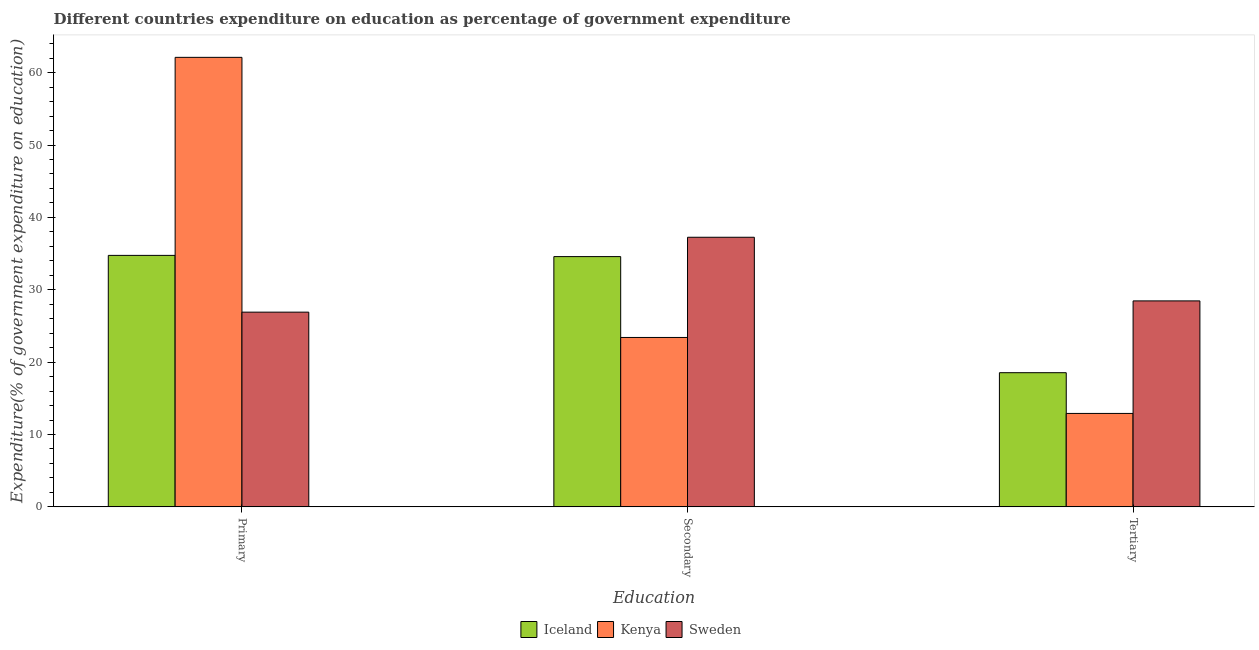How many different coloured bars are there?
Give a very brief answer. 3. How many bars are there on the 3rd tick from the left?
Ensure brevity in your answer.  3. How many bars are there on the 3rd tick from the right?
Provide a succinct answer. 3. What is the label of the 1st group of bars from the left?
Ensure brevity in your answer.  Primary. What is the expenditure on secondary education in Kenya?
Provide a succinct answer. 23.41. Across all countries, what is the maximum expenditure on secondary education?
Offer a very short reply. 37.26. Across all countries, what is the minimum expenditure on primary education?
Your response must be concise. 26.91. In which country was the expenditure on primary education maximum?
Offer a very short reply. Kenya. In which country was the expenditure on tertiary education minimum?
Make the answer very short. Kenya. What is the total expenditure on secondary education in the graph?
Give a very brief answer. 95.25. What is the difference between the expenditure on tertiary education in Iceland and that in Kenya?
Your answer should be very brief. 5.63. What is the difference between the expenditure on tertiary education in Iceland and the expenditure on secondary education in Kenya?
Make the answer very short. -4.87. What is the average expenditure on primary education per country?
Ensure brevity in your answer.  41.26. What is the difference between the expenditure on tertiary education and expenditure on secondary education in Iceland?
Keep it short and to the point. -16.04. In how many countries, is the expenditure on tertiary education greater than 42 %?
Offer a terse response. 0. What is the ratio of the expenditure on secondary education in Sweden to that in Kenya?
Your answer should be very brief. 1.59. Is the expenditure on secondary education in Kenya less than that in Iceland?
Your response must be concise. Yes. What is the difference between the highest and the second highest expenditure on secondary education?
Give a very brief answer. 2.67. What is the difference between the highest and the lowest expenditure on primary education?
Make the answer very short. 35.21. Is the sum of the expenditure on primary education in Kenya and Sweden greater than the maximum expenditure on tertiary education across all countries?
Your response must be concise. Yes. What does the 2nd bar from the left in Secondary represents?
Offer a terse response. Kenya. Are all the bars in the graph horizontal?
Keep it short and to the point. No. What is the difference between two consecutive major ticks on the Y-axis?
Keep it short and to the point. 10. Does the graph contain grids?
Keep it short and to the point. No. How are the legend labels stacked?
Offer a very short reply. Horizontal. What is the title of the graph?
Keep it short and to the point. Different countries expenditure on education as percentage of government expenditure. What is the label or title of the X-axis?
Keep it short and to the point. Education. What is the label or title of the Y-axis?
Give a very brief answer. Expenditure(% of government expenditure on education). What is the Expenditure(% of government expenditure on education) in Iceland in Primary?
Offer a very short reply. 34.75. What is the Expenditure(% of government expenditure on education) of Kenya in Primary?
Your answer should be very brief. 62.12. What is the Expenditure(% of government expenditure on education) of Sweden in Primary?
Ensure brevity in your answer.  26.91. What is the Expenditure(% of government expenditure on education) in Iceland in Secondary?
Keep it short and to the point. 34.58. What is the Expenditure(% of government expenditure on education) of Kenya in Secondary?
Keep it short and to the point. 23.41. What is the Expenditure(% of government expenditure on education) of Sweden in Secondary?
Make the answer very short. 37.26. What is the Expenditure(% of government expenditure on education) of Iceland in Tertiary?
Your response must be concise. 18.54. What is the Expenditure(% of government expenditure on education) of Kenya in Tertiary?
Ensure brevity in your answer.  12.91. What is the Expenditure(% of government expenditure on education) in Sweden in Tertiary?
Give a very brief answer. 28.46. Across all Education, what is the maximum Expenditure(% of government expenditure on education) of Iceland?
Keep it short and to the point. 34.75. Across all Education, what is the maximum Expenditure(% of government expenditure on education) of Kenya?
Make the answer very short. 62.12. Across all Education, what is the maximum Expenditure(% of government expenditure on education) of Sweden?
Offer a terse response. 37.26. Across all Education, what is the minimum Expenditure(% of government expenditure on education) in Iceland?
Offer a terse response. 18.54. Across all Education, what is the minimum Expenditure(% of government expenditure on education) in Kenya?
Your response must be concise. 12.91. Across all Education, what is the minimum Expenditure(% of government expenditure on education) in Sweden?
Give a very brief answer. 26.91. What is the total Expenditure(% of government expenditure on education) of Iceland in the graph?
Provide a succinct answer. 87.87. What is the total Expenditure(% of government expenditure on education) in Kenya in the graph?
Your answer should be compact. 98.44. What is the total Expenditure(% of government expenditure on education) in Sweden in the graph?
Keep it short and to the point. 92.62. What is the difference between the Expenditure(% of government expenditure on education) of Iceland in Primary and that in Secondary?
Keep it short and to the point. 0.17. What is the difference between the Expenditure(% of government expenditure on education) of Kenya in Primary and that in Secondary?
Keep it short and to the point. 38.71. What is the difference between the Expenditure(% of government expenditure on education) of Sweden in Primary and that in Secondary?
Keep it short and to the point. -10.35. What is the difference between the Expenditure(% of government expenditure on education) of Iceland in Primary and that in Tertiary?
Your response must be concise. 16.21. What is the difference between the Expenditure(% of government expenditure on education) in Kenya in Primary and that in Tertiary?
Your answer should be very brief. 49.21. What is the difference between the Expenditure(% of government expenditure on education) in Sweden in Primary and that in Tertiary?
Offer a terse response. -1.56. What is the difference between the Expenditure(% of government expenditure on education) in Iceland in Secondary and that in Tertiary?
Provide a succinct answer. 16.04. What is the difference between the Expenditure(% of government expenditure on education) of Kenya in Secondary and that in Tertiary?
Provide a succinct answer. 10.5. What is the difference between the Expenditure(% of government expenditure on education) of Sweden in Secondary and that in Tertiary?
Make the answer very short. 8.79. What is the difference between the Expenditure(% of government expenditure on education) of Iceland in Primary and the Expenditure(% of government expenditure on education) of Kenya in Secondary?
Your answer should be compact. 11.34. What is the difference between the Expenditure(% of government expenditure on education) in Iceland in Primary and the Expenditure(% of government expenditure on education) in Sweden in Secondary?
Ensure brevity in your answer.  -2.5. What is the difference between the Expenditure(% of government expenditure on education) of Kenya in Primary and the Expenditure(% of government expenditure on education) of Sweden in Secondary?
Give a very brief answer. 24.86. What is the difference between the Expenditure(% of government expenditure on education) in Iceland in Primary and the Expenditure(% of government expenditure on education) in Kenya in Tertiary?
Your answer should be very brief. 21.84. What is the difference between the Expenditure(% of government expenditure on education) of Iceland in Primary and the Expenditure(% of government expenditure on education) of Sweden in Tertiary?
Give a very brief answer. 6.29. What is the difference between the Expenditure(% of government expenditure on education) of Kenya in Primary and the Expenditure(% of government expenditure on education) of Sweden in Tertiary?
Provide a succinct answer. 33.66. What is the difference between the Expenditure(% of government expenditure on education) in Iceland in Secondary and the Expenditure(% of government expenditure on education) in Kenya in Tertiary?
Your answer should be compact. 21.67. What is the difference between the Expenditure(% of government expenditure on education) in Iceland in Secondary and the Expenditure(% of government expenditure on education) in Sweden in Tertiary?
Provide a succinct answer. 6.12. What is the difference between the Expenditure(% of government expenditure on education) in Kenya in Secondary and the Expenditure(% of government expenditure on education) in Sweden in Tertiary?
Your answer should be very brief. -5.05. What is the average Expenditure(% of government expenditure on education) of Iceland per Education?
Give a very brief answer. 29.29. What is the average Expenditure(% of government expenditure on education) of Kenya per Education?
Keep it short and to the point. 32.81. What is the average Expenditure(% of government expenditure on education) in Sweden per Education?
Your answer should be compact. 30.87. What is the difference between the Expenditure(% of government expenditure on education) of Iceland and Expenditure(% of government expenditure on education) of Kenya in Primary?
Offer a very short reply. -27.37. What is the difference between the Expenditure(% of government expenditure on education) in Iceland and Expenditure(% of government expenditure on education) in Sweden in Primary?
Your response must be concise. 7.84. What is the difference between the Expenditure(% of government expenditure on education) of Kenya and Expenditure(% of government expenditure on education) of Sweden in Primary?
Offer a terse response. 35.21. What is the difference between the Expenditure(% of government expenditure on education) in Iceland and Expenditure(% of government expenditure on education) in Kenya in Secondary?
Keep it short and to the point. 11.17. What is the difference between the Expenditure(% of government expenditure on education) of Iceland and Expenditure(% of government expenditure on education) of Sweden in Secondary?
Your answer should be compact. -2.67. What is the difference between the Expenditure(% of government expenditure on education) of Kenya and Expenditure(% of government expenditure on education) of Sweden in Secondary?
Provide a succinct answer. -13.85. What is the difference between the Expenditure(% of government expenditure on education) in Iceland and Expenditure(% of government expenditure on education) in Kenya in Tertiary?
Give a very brief answer. 5.63. What is the difference between the Expenditure(% of government expenditure on education) of Iceland and Expenditure(% of government expenditure on education) of Sweden in Tertiary?
Offer a very short reply. -9.92. What is the difference between the Expenditure(% of government expenditure on education) in Kenya and Expenditure(% of government expenditure on education) in Sweden in Tertiary?
Provide a short and direct response. -15.55. What is the ratio of the Expenditure(% of government expenditure on education) of Kenya in Primary to that in Secondary?
Your response must be concise. 2.65. What is the ratio of the Expenditure(% of government expenditure on education) in Sweden in Primary to that in Secondary?
Provide a short and direct response. 0.72. What is the ratio of the Expenditure(% of government expenditure on education) of Iceland in Primary to that in Tertiary?
Ensure brevity in your answer.  1.87. What is the ratio of the Expenditure(% of government expenditure on education) in Kenya in Primary to that in Tertiary?
Offer a terse response. 4.81. What is the ratio of the Expenditure(% of government expenditure on education) in Sweden in Primary to that in Tertiary?
Ensure brevity in your answer.  0.95. What is the ratio of the Expenditure(% of government expenditure on education) of Iceland in Secondary to that in Tertiary?
Your answer should be very brief. 1.87. What is the ratio of the Expenditure(% of government expenditure on education) in Kenya in Secondary to that in Tertiary?
Your answer should be compact. 1.81. What is the ratio of the Expenditure(% of government expenditure on education) of Sweden in Secondary to that in Tertiary?
Offer a terse response. 1.31. What is the difference between the highest and the second highest Expenditure(% of government expenditure on education) of Iceland?
Your response must be concise. 0.17. What is the difference between the highest and the second highest Expenditure(% of government expenditure on education) of Kenya?
Provide a succinct answer. 38.71. What is the difference between the highest and the second highest Expenditure(% of government expenditure on education) of Sweden?
Offer a terse response. 8.79. What is the difference between the highest and the lowest Expenditure(% of government expenditure on education) of Iceland?
Your response must be concise. 16.21. What is the difference between the highest and the lowest Expenditure(% of government expenditure on education) in Kenya?
Your answer should be compact. 49.21. What is the difference between the highest and the lowest Expenditure(% of government expenditure on education) of Sweden?
Offer a terse response. 10.35. 